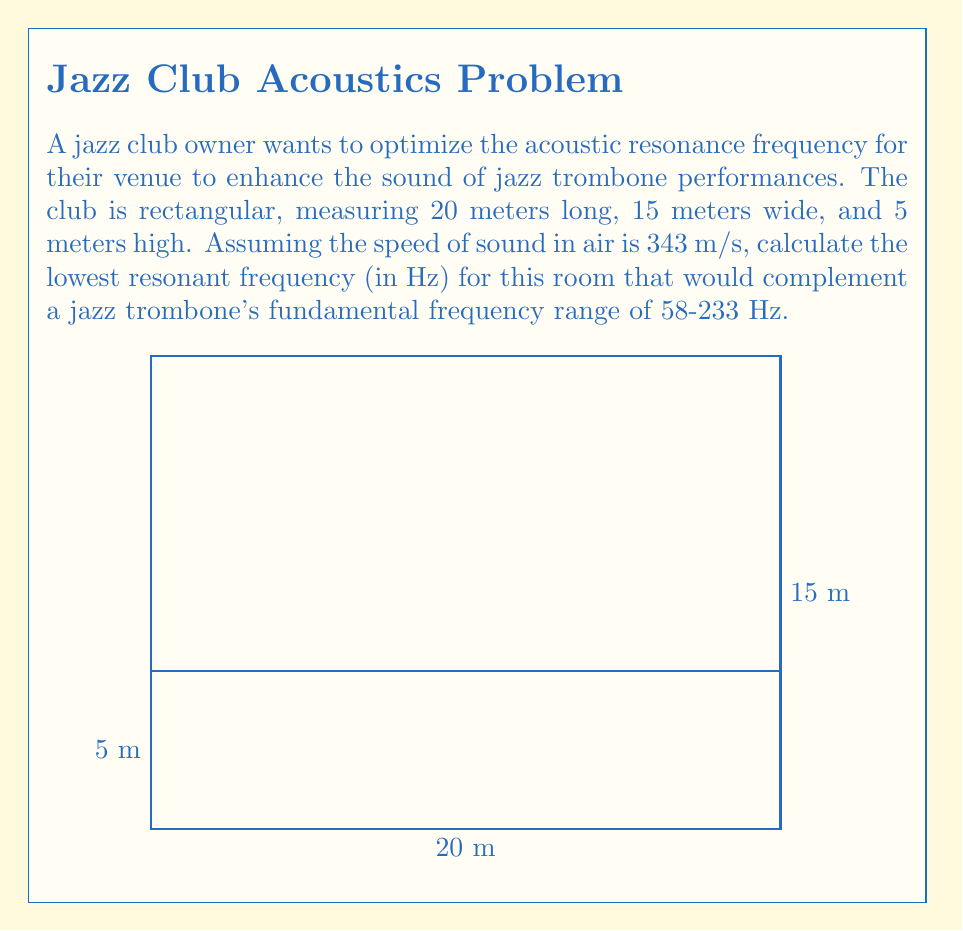Show me your answer to this math problem. To solve this problem, we'll use the room mode formula for rectangular spaces:

$$f = \frac{c}{2} \sqrt{\left(\frac{n_x}{L_x}\right)^2 + \left(\frac{n_y}{L_y}\right)^2 + \left(\frac{n_z}{L_z}\right)^2}$$

Where:
- $f$ is the resonant frequency
- $c$ is the speed of sound in air (343 m/s)
- $L_x$, $L_y$, and $L_z$ are the room dimensions (20 m, 15 m, and 5 m respectively)
- $n_x$, $n_y$, and $n_z$ are mode numbers (integers ≥ 0, not all zero)

The lowest resonant frequency occurs when $n_x = 1$, $n_y = 0$, and $n_z = 0$. Substituting these values:

$$f = \frac{343}{2} \sqrt{\left(\frac{1}{20}\right)^2 + \left(\frac{0}{15}\right)^2 + \left(\frac{0}{5}\right)^2}$$

$$f = \frac{343}{2} \sqrt{\frac{1}{400}}$$

$$f = \frac{343}{2} \cdot \frac{1}{20}$$

$$f = \frac{343}{40} = 8.575 \text{ Hz}$$

This frequency is below the fundamental frequency range of a jazz trombone (58-233 Hz). The next higher mode that falls within this range would be when $n_x = 3$, $n_y = 0$, and $n_z = 0$:

$$f = \frac{343}{2} \sqrt{\left(\frac{3}{20}\right)^2 + \left(\frac{0}{15}\right)^2 + \left(\frac{0}{5}\right)^2}$$

$$f = \frac{343}{2} \sqrt{\frac{9}{400}}$$

$$f = \frac{343}{2} \cdot \frac{3}{20}$$

$$f = \frac{343 \cdot 3}{40} = 25.725 \text{ Hz}$$

The next mode ($n_x = 4$, $n_y = 0$, $n_z = 0$) gives us:

$$f = \frac{343 \cdot 4}{40} = 34.3 \text{ Hz}$$

Continuing this process, we find that the lowest resonant frequency within the trombone's range is when $n_x = 7$, $n_y = 0$, $n_z = 0$:

$$f = \frac{343 \cdot 7}{40} = 60.025 \text{ Hz}$$

This frequency falls within the jazz trombone's fundamental frequency range and would complement the instrument's sound in the club.
Answer: 60.025 Hz 